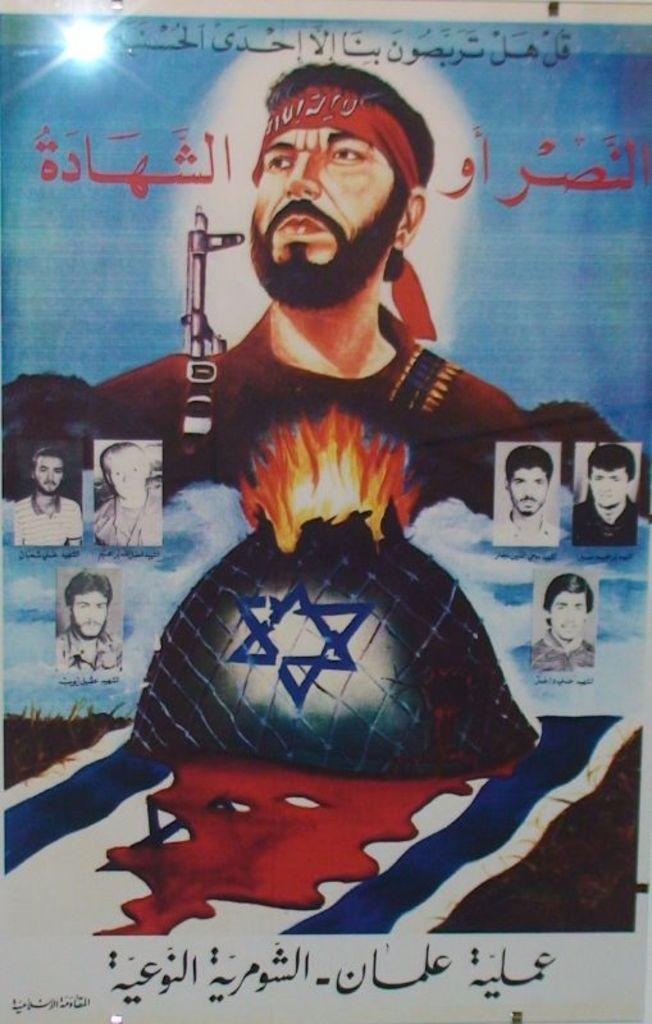What type of visual is the image? The image is a poster. What can be found on the poster besides images? There is text on the poster. What type of element is depicted in the image on the poster? There is an image of fire on the poster. Who or what is depicted on the poster? There are people depicted on the poster. What other elements are depicted on the poster? There is a flag and grass depicted on the poster. Can you see a spy hiding behind the grass on the poster? There is no spy depicted on the poster; it features people, a flag, and grass, but no hidden spies. What type of wood is used to make the flagpole in the image? There is no flagpole depicted in the image, and therefore no wood can be observed. 